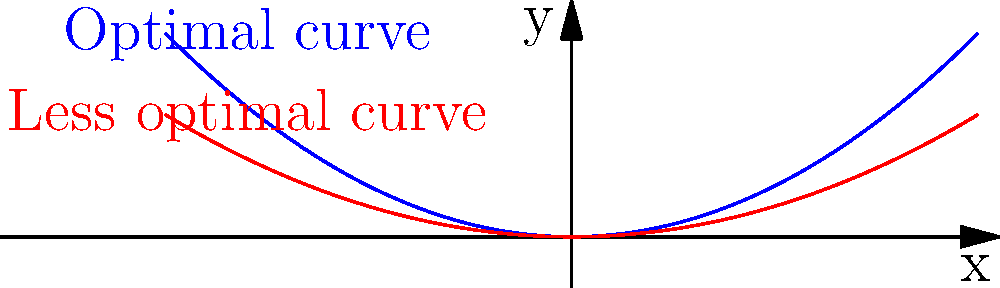In luxury car modifications, the curvature of a car's side panels plays a crucial role in both aesthetics and aerodynamics. Consider two potential curvature functions for a car's side panel: $f(x) = 0.05x^2$ and $g(x) = 0.03x^2$, where $x$ is the horizontal distance from the car's centerline in meters, and $f(x)$ or $g(x)$ represents the vertical distance from the baseline in meters. Which function provides the optimal curvature for improved aesthetics and performance, and why? To determine the optimal curvature, we need to consider both aesthetics and performance:

1. Aesthetics: A more pronounced curve (higher coefficient) generally creates a more dramatic and luxurious appearance.

2. Aerodynamics: The curvature affects air flow around the car. A more pronounced curve can help reduce drag by allowing air to flow more smoothly along the car's body.

3. Comparing the functions:
   $f(x) = 0.05x^2$ (blue curve)
   $g(x) = 0.03x^2$ (red curve)

4. The coefficient in $f(x)$ (0.05) is larger than in $g(x)$ (0.03), meaning $f(x)$ creates a more pronounced curve.

5. At any given x value, $f(x)$ will have a higher y-value, resulting in a more dramatic side panel profile.

6. The steeper curve of $f(x)$ allows for better air flow management, potentially reducing drag and improving performance.

7. The more pronounced curve of $f(x)$ also creates a more luxurious and unique appearance, aligning with the goal of creating a masterpiece in luxury car modifications.

Therefore, $f(x) = 0.05x^2$ provides the optimal curvature for improved aesthetics and performance.
Answer: $f(x) = 0.05x^2$ 